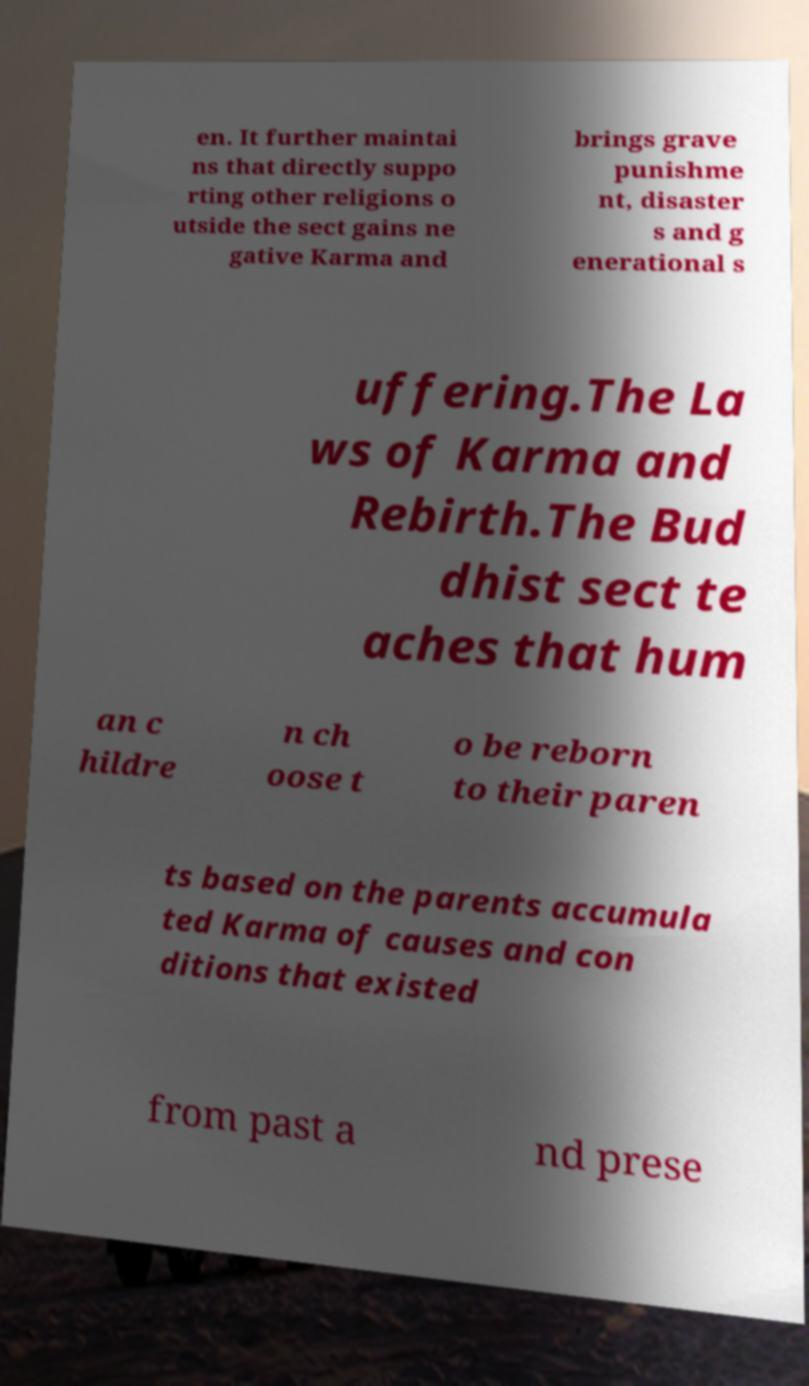Could you assist in decoding the text presented in this image and type it out clearly? en. It further maintai ns that directly suppo rting other religions o utside the sect gains ne gative Karma and brings grave punishme nt, disaster s and g enerational s uffering.The La ws of Karma and Rebirth.The Bud dhist sect te aches that hum an c hildre n ch oose t o be reborn to their paren ts based on the parents accumula ted Karma of causes and con ditions that existed from past a nd prese 